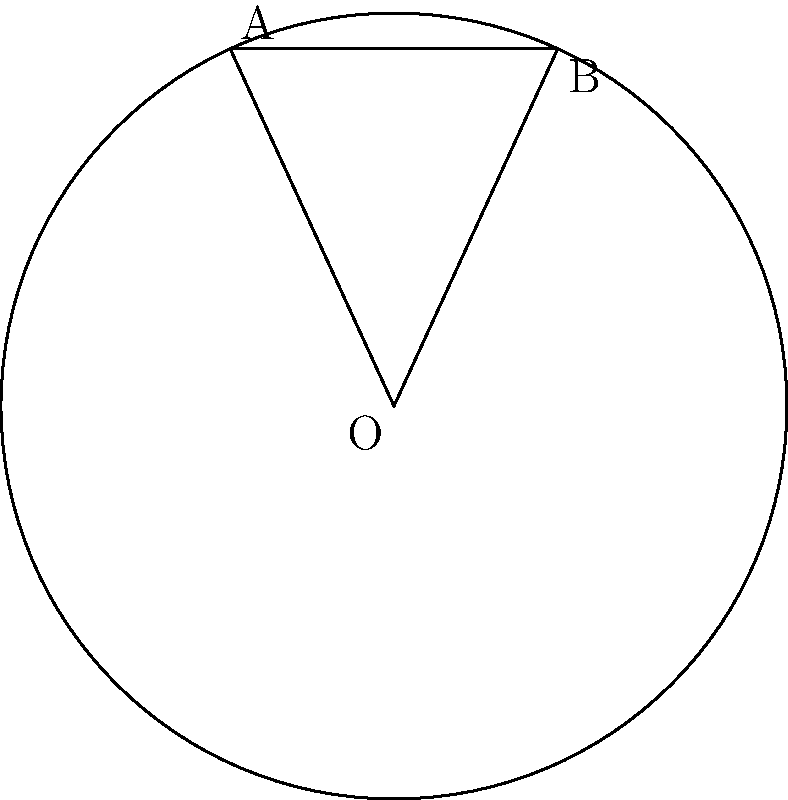In the context of neural network architecture optimization, consider a circular segment formed by a chord in a circle. Given a circle with radius $r = 3$ units and a chord length $c = 2.5$ units, calculate the area of the circular segment. How might this geometric problem relate to optimizing the receptive field of convolutional neural networks? To calculate the area of the circular segment, we'll follow these steps:

1) First, we need to find the central angle $\theta$ using the chord length and radius:
   $$\theta = 2 \arcsin(\frac{c}{2r}) = 2 \arcsin(\frac{2.5}{2 \cdot 3}) \approx 0.9273 \text{ radians}$$

2) The area of a circular segment is given by the formula:
   $$A = r^2 \arccos(\frac{r-h}{r}) - (r-h)\sqrt{2rh-h^2}$$
   where $h$ is the height of the segment.

3) We can find $h$ using:
   $$h = r - r\cos(\frac{\theta}{2}) = 3 - 3\cos(\frac{0.9273}{2}) \approx 0.2789$$

4) Now we can substitute these values into the area formula:
   $$A = 3^2 \arccos(\frac{3-0.2789}{3}) - (3-0.2789)\sqrt{2 \cdot 3 \cdot 0.2789 - 0.2789^2}$$

5) Simplifying:
   $$A \approx 9 \cdot 0.4636 - 2.7211 \cdot 1.2732 \approx 0.7634$$

This geometric problem relates to optimizing the receptive field of convolutional neural networks (CNNs) in several ways:

1) The circular segment can represent the effective receptive field of a neuron in a CNN.
2) The radius $r$ could correspond to the maximum theoretical receptive field size.
3) The chord length $c$ might represent the actual effective range of the neuron's sensitivity.
4) The area of the segment could quantify the neuron's influence on the input space.

Understanding these geometric relationships can help in designing more efficient CNN architectures by optimizing filter sizes and stride lengths to achieve desired receptive fields.
Answer: $0.7634$ square units 